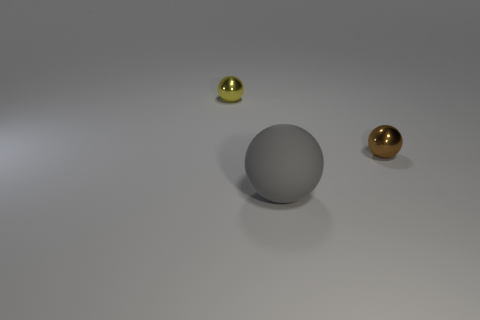Add 3 big gray rubber balls. How many objects exist? 6 Subtract all rubber balls. How many balls are left? 2 Subtract all large balls. Subtract all yellow spheres. How many objects are left? 1 Add 3 yellow spheres. How many yellow spheres are left? 4 Add 3 gray rubber balls. How many gray rubber balls exist? 4 Subtract all yellow spheres. How many spheres are left? 2 Subtract 1 brown spheres. How many objects are left? 2 Subtract all yellow spheres. Subtract all gray blocks. How many spheres are left? 2 Subtract all green blocks. How many gray balls are left? 1 